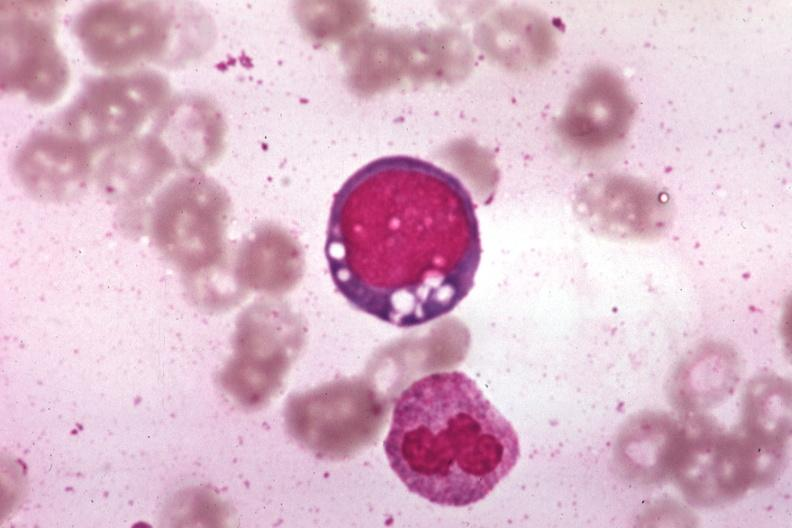s carcinoma metastatic lung present?
Answer the question using a single word or phrase. No 